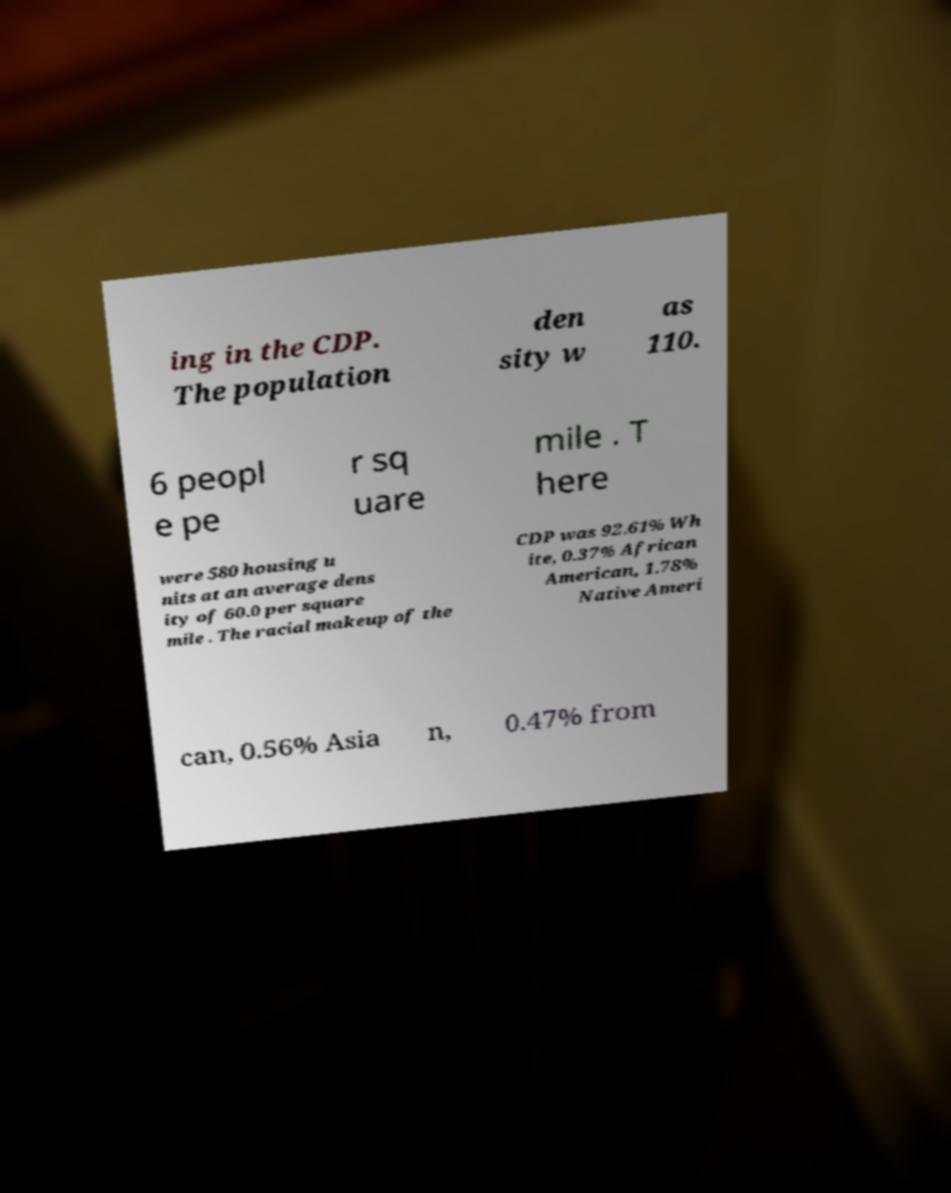I need the written content from this picture converted into text. Can you do that? ing in the CDP. The population den sity w as 110. 6 peopl e pe r sq uare mile . T here were 580 housing u nits at an average dens ity of 60.0 per square mile . The racial makeup of the CDP was 92.61% Wh ite, 0.37% African American, 1.78% Native Ameri can, 0.56% Asia n, 0.47% from 